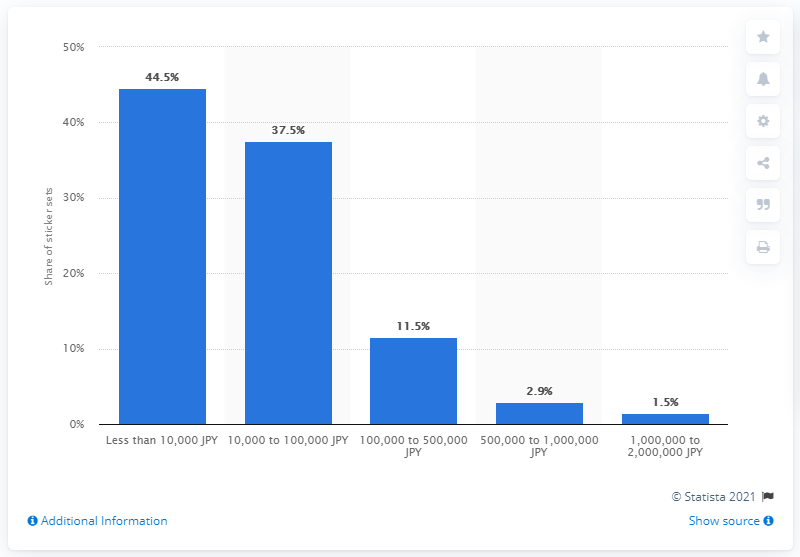Outline some significant characteristics in this image. As of August 2014, 2.9% of sticker sets had reached sales of 500,000 to 1 million yen. 